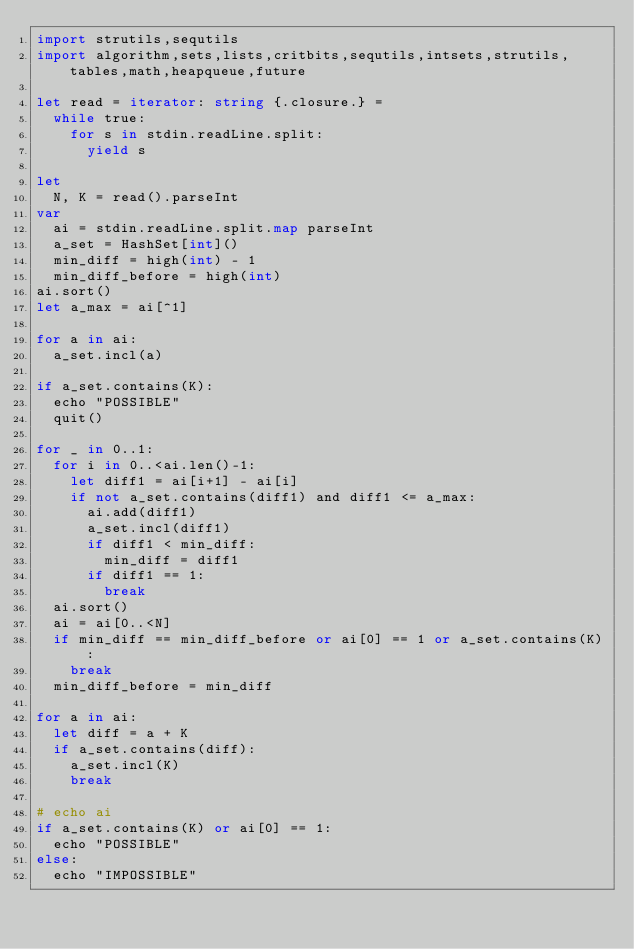Convert code to text. <code><loc_0><loc_0><loc_500><loc_500><_Nim_>import strutils,sequtils
import algorithm,sets,lists,critbits,sequtils,intsets,strutils,tables,math,heapqueue,future

let read = iterator: string {.closure.} =
  while true:
    for s in stdin.readLine.split:
      yield s

let
  N, K = read().parseInt
var
  ai = stdin.readLine.split.map parseInt
  a_set = HashSet[int]()
  min_diff = high(int) - 1
  min_diff_before = high(int)
ai.sort()
let a_max = ai[^1]

for a in ai:
  a_set.incl(a)

if a_set.contains(K):
  echo "POSSIBLE"
  quit()

for _ in 0..1:
  for i in 0..<ai.len()-1:
    let diff1 = ai[i+1] - ai[i]
    if not a_set.contains(diff1) and diff1 <= a_max:
      ai.add(diff1)
      a_set.incl(diff1)
      if diff1 < min_diff:
        min_diff = diff1
      if diff1 == 1:
        break
  ai.sort()
  ai = ai[0..<N]
  if min_diff == min_diff_before or ai[0] == 1 or a_set.contains(K):
    break
  min_diff_before = min_diff

for a in ai:
  let diff = a + K
  if a_set.contains(diff):
    a_set.incl(K)
    break

# echo ai
if a_set.contains(K) or ai[0] == 1:
  echo "POSSIBLE"
else:
  echo "IMPOSSIBLE"
</code> 